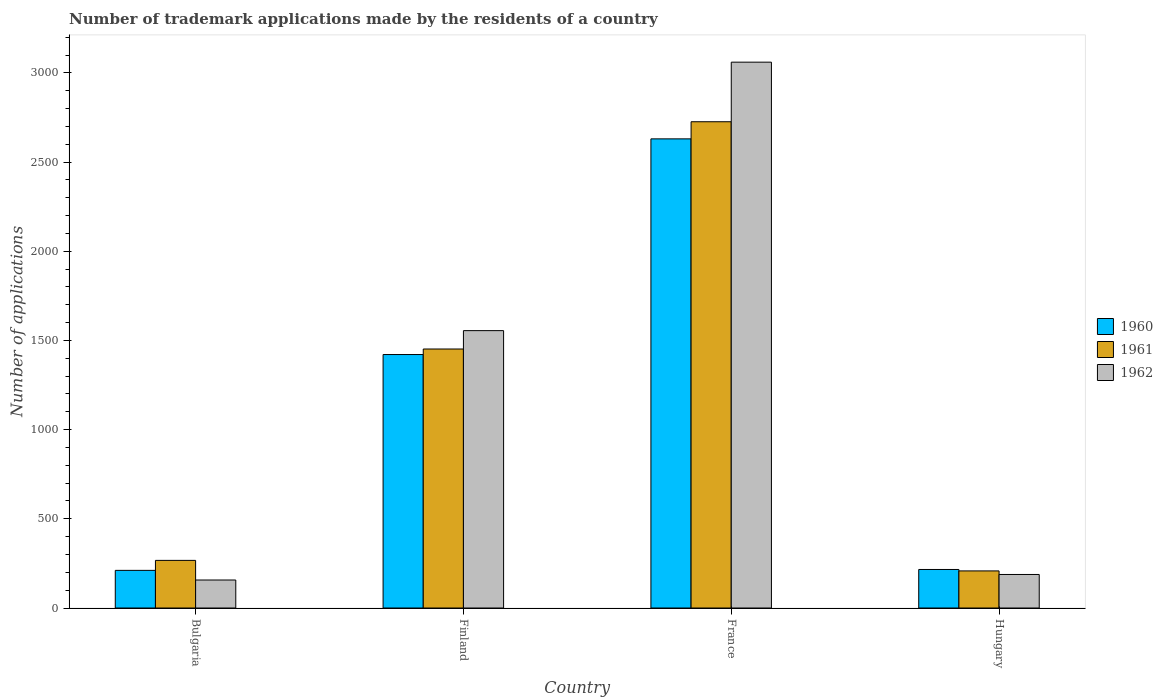How many groups of bars are there?
Give a very brief answer. 4. Are the number of bars per tick equal to the number of legend labels?
Your response must be concise. Yes. What is the label of the 4th group of bars from the left?
Provide a short and direct response. Hungary. What is the number of trademark applications made by the residents in 1961 in Bulgaria?
Offer a very short reply. 267. Across all countries, what is the maximum number of trademark applications made by the residents in 1961?
Offer a very short reply. 2726. Across all countries, what is the minimum number of trademark applications made by the residents in 1961?
Keep it short and to the point. 208. In which country was the number of trademark applications made by the residents in 1961 maximum?
Your answer should be compact. France. In which country was the number of trademark applications made by the residents in 1962 minimum?
Offer a very short reply. Bulgaria. What is the total number of trademark applications made by the residents in 1960 in the graph?
Provide a succinct answer. 4478. What is the difference between the number of trademark applications made by the residents in 1960 in Bulgaria and that in Finland?
Make the answer very short. -1210. What is the difference between the number of trademark applications made by the residents in 1961 in Bulgaria and the number of trademark applications made by the residents in 1962 in Hungary?
Provide a succinct answer. 79. What is the average number of trademark applications made by the residents in 1961 per country?
Your response must be concise. 1163.25. What is the difference between the number of trademark applications made by the residents of/in 1962 and number of trademark applications made by the residents of/in 1960 in Finland?
Make the answer very short. 134. In how many countries, is the number of trademark applications made by the residents in 1961 greater than 100?
Your answer should be very brief. 4. What is the ratio of the number of trademark applications made by the residents in 1960 in Finland to that in France?
Your response must be concise. 0.54. Is the number of trademark applications made by the residents in 1961 in Finland less than that in Hungary?
Provide a short and direct response. No. Is the difference between the number of trademark applications made by the residents in 1962 in Bulgaria and France greater than the difference between the number of trademark applications made by the residents in 1960 in Bulgaria and France?
Give a very brief answer. No. What is the difference between the highest and the second highest number of trademark applications made by the residents in 1961?
Offer a terse response. -1185. What is the difference between the highest and the lowest number of trademark applications made by the residents in 1962?
Your answer should be compact. 2903. Is it the case that in every country, the sum of the number of trademark applications made by the residents in 1962 and number of trademark applications made by the residents in 1960 is greater than the number of trademark applications made by the residents in 1961?
Offer a terse response. Yes. How many countries are there in the graph?
Provide a short and direct response. 4. Does the graph contain any zero values?
Keep it short and to the point. No. Does the graph contain grids?
Provide a succinct answer. No. Where does the legend appear in the graph?
Offer a terse response. Center right. How many legend labels are there?
Offer a terse response. 3. How are the legend labels stacked?
Provide a short and direct response. Vertical. What is the title of the graph?
Keep it short and to the point. Number of trademark applications made by the residents of a country. Does "1969" appear as one of the legend labels in the graph?
Offer a terse response. No. What is the label or title of the X-axis?
Give a very brief answer. Country. What is the label or title of the Y-axis?
Your answer should be very brief. Number of applications. What is the Number of applications of 1960 in Bulgaria?
Your answer should be compact. 211. What is the Number of applications of 1961 in Bulgaria?
Ensure brevity in your answer.  267. What is the Number of applications in 1962 in Bulgaria?
Ensure brevity in your answer.  157. What is the Number of applications in 1960 in Finland?
Provide a succinct answer. 1421. What is the Number of applications of 1961 in Finland?
Your response must be concise. 1452. What is the Number of applications in 1962 in Finland?
Your answer should be compact. 1555. What is the Number of applications in 1960 in France?
Your response must be concise. 2630. What is the Number of applications of 1961 in France?
Your answer should be compact. 2726. What is the Number of applications of 1962 in France?
Offer a very short reply. 3060. What is the Number of applications in 1960 in Hungary?
Provide a succinct answer. 216. What is the Number of applications in 1961 in Hungary?
Make the answer very short. 208. What is the Number of applications of 1962 in Hungary?
Keep it short and to the point. 188. Across all countries, what is the maximum Number of applications of 1960?
Your answer should be compact. 2630. Across all countries, what is the maximum Number of applications of 1961?
Your answer should be compact. 2726. Across all countries, what is the maximum Number of applications in 1962?
Make the answer very short. 3060. Across all countries, what is the minimum Number of applications in 1960?
Keep it short and to the point. 211. Across all countries, what is the minimum Number of applications in 1961?
Your answer should be very brief. 208. Across all countries, what is the minimum Number of applications in 1962?
Your answer should be very brief. 157. What is the total Number of applications in 1960 in the graph?
Provide a short and direct response. 4478. What is the total Number of applications of 1961 in the graph?
Your answer should be compact. 4653. What is the total Number of applications of 1962 in the graph?
Offer a very short reply. 4960. What is the difference between the Number of applications of 1960 in Bulgaria and that in Finland?
Offer a very short reply. -1210. What is the difference between the Number of applications in 1961 in Bulgaria and that in Finland?
Your answer should be compact. -1185. What is the difference between the Number of applications in 1962 in Bulgaria and that in Finland?
Make the answer very short. -1398. What is the difference between the Number of applications in 1960 in Bulgaria and that in France?
Provide a short and direct response. -2419. What is the difference between the Number of applications in 1961 in Bulgaria and that in France?
Keep it short and to the point. -2459. What is the difference between the Number of applications of 1962 in Bulgaria and that in France?
Your answer should be very brief. -2903. What is the difference between the Number of applications in 1962 in Bulgaria and that in Hungary?
Provide a short and direct response. -31. What is the difference between the Number of applications of 1960 in Finland and that in France?
Offer a terse response. -1209. What is the difference between the Number of applications of 1961 in Finland and that in France?
Ensure brevity in your answer.  -1274. What is the difference between the Number of applications of 1962 in Finland and that in France?
Ensure brevity in your answer.  -1505. What is the difference between the Number of applications of 1960 in Finland and that in Hungary?
Offer a very short reply. 1205. What is the difference between the Number of applications of 1961 in Finland and that in Hungary?
Your answer should be very brief. 1244. What is the difference between the Number of applications of 1962 in Finland and that in Hungary?
Give a very brief answer. 1367. What is the difference between the Number of applications of 1960 in France and that in Hungary?
Offer a terse response. 2414. What is the difference between the Number of applications of 1961 in France and that in Hungary?
Your answer should be very brief. 2518. What is the difference between the Number of applications of 1962 in France and that in Hungary?
Offer a terse response. 2872. What is the difference between the Number of applications in 1960 in Bulgaria and the Number of applications in 1961 in Finland?
Provide a short and direct response. -1241. What is the difference between the Number of applications in 1960 in Bulgaria and the Number of applications in 1962 in Finland?
Provide a short and direct response. -1344. What is the difference between the Number of applications in 1961 in Bulgaria and the Number of applications in 1962 in Finland?
Ensure brevity in your answer.  -1288. What is the difference between the Number of applications in 1960 in Bulgaria and the Number of applications in 1961 in France?
Your answer should be compact. -2515. What is the difference between the Number of applications of 1960 in Bulgaria and the Number of applications of 1962 in France?
Give a very brief answer. -2849. What is the difference between the Number of applications of 1961 in Bulgaria and the Number of applications of 1962 in France?
Make the answer very short. -2793. What is the difference between the Number of applications in 1960 in Bulgaria and the Number of applications in 1961 in Hungary?
Your response must be concise. 3. What is the difference between the Number of applications in 1960 in Bulgaria and the Number of applications in 1962 in Hungary?
Your answer should be very brief. 23. What is the difference between the Number of applications of 1961 in Bulgaria and the Number of applications of 1962 in Hungary?
Offer a very short reply. 79. What is the difference between the Number of applications of 1960 in Finland and the Number of applications of 1961 in France?
Provide a succinct answer. -1305. What is the difference between the Number of applications in 1960 in Finland and the Number of applications in 1962 in France?
Offer a terse response. -1639. What is the difference between the Number of applications of 1961 in Finland and the Number of applications of 1962 in France?
Your answer should be very brief. -1608. What is the difference between the Number of applications of 1960 in Finland and the Number of applications of 1961 in Hungary?
Ensure brevity in your answer.  1213. What is the difference between the Number of applications of 1960 in Finland and the Number of applications of 1962 in Hungary?
Offer a very short reply. 1233. What is the difference between the Number of applications in 1961 in Finland and the Number of applications in 1962 in Hungary?
Offer a terse response. 1264. What is the difference between the Number of applications in 1960 in France and the Number of applications in 1961 in Hungary?
Ensure brevity in your answer.  2422. What is the difference between the Number of applications in 1960 in France and the Number of applications in 1962 in Hungary?
Offer a terse response. 2442. What is the difference between the Number of applications of 1961 in France and the Number of applications of 1962 in Hungary?
Provide a succinct answer. 2538. What is the average Number of applications in 1960 per country?
Give a very brief answer. 1119.5. What is the average Number of applications in 1961 per country?
Your answer should be compact. 1163.25. What is the average Number of applications in 1962 per country?
Keep it short and to the point. 1240. What is the difference between the Number of applications of 1960 and Number of applications of 1961 in Bulgaria?
Ensure brevity in your answer.  -56. What is the difference between the Number of applications in 1960 and Number of applications in 1962 in Bulgaria?
Your answer should be compact. 54. What is the difference between the Number of applications in 1961 and Number of applications in 1962 in Bulgaria?
Ensure brevity in your answer.  110. What is the difference between the Number of applications in 1960 and Number of applications in 1961 in Finland?
Your answer should be very brief. -31. What is the difference between the Number of applications in 1960 and Number of applications in 1962 in Finland?
Keep it short and to the point. -134. What is the difference between the Number of applications of 1961 and Number of applications of 1962 in Finland?
Provide a short and direct response. -103. What is the difference between the Number of applications in 1960 and Number of applications in 1961 in France?
Offer a very short reply. -96. What is the difference between the Number of applications of 1960 and Number of applications of 1962 in France?
Provide a succinct answer. -430. What is the difference between the Number of applications of 1961 and Number of applications of 1962 in France?
Give a very brief answer. -334. What is the ratio of the Number of applications of 1960 in Bulgaria to that in Finland?
Your response must be concise. 0.15. What is the ratio of the Number of applications in 1961 in Bulgaria to that in Finland?
Keep it short and to the point. 0.18. What is the ratio of the Number of applications of 1962 in Bulgaria to that in Finland?
Keep it short and to the point. 0.1. What is the ratio of the Number of applications of 1960 in Bulgaria to that in France?
Offer a terse response. 0.08. What is the ratio of the Number of applications in 1961 in Bulgaria to that in France?
Your response must be concise. 0.1. What is the ratio of the Number of applications in 1962 in Bulgaria to that in France?
Offer a terse response. 0.05. What is the ratio of the Number of applications in 1960 in Bulgaria to that in Hungary?
Provide a succinct answer. 0.98. What is the ratio of the Number of applications in 1961 in Bulgaria to that in Hungary?
Offer a terse response. 1.28. What is the ratio of the Number of applications of 1962 in Bulgaria to that in Hungary?
Your answer should be very brief. 0.84. What is the ratio of the Number of applications in 1960 in Finland to that in France?
Offer a terse response. 0.54. What is the ratio of the Number of applications in 1961 in Finland to that in France?
Ensure brevity in your answer.  0.53. What is the ratio of the Number of applications in 1962 in Finland to that in France?
Your answer should be very brief. 0.51. What is the ratio of the Number of applications of 1960 in Finland to that in Hungary?
Ensure brevity in your answer.  6.58. What is the ratio of the Number of applications in 1961 in Finland to that in Hungary?
Give a very brief answer. 6.98. What is the ratio of the Number of applications of 1962 in Finland to that in Hungary?
Your answer should be very brief. 8.27. What is the ratio of the Number of applications in 1960 in France to that in Hungary?
Your answer should be compact. 12.18. What is the ratio of the Number of applications in 1961 in France to that in Hungary?
Offer a terse response. 13.11. What is the ratio of the Number of applications of 1962 in France to that in Hungary?
Offer a very short reply. 16.28. What is the difference between the highest and the second highest Number of applications of 1960?
Your response must be concise. 1209. What is the difference between the highest and the second highest Number of applications of 1961?
Give a very brief answer. 1274. What is the difference between the highest and the second highest Number of applications of 1962?
Give a very brief answer. 1505. What is the difference between the highest and the lowest Number of applications in 1960?
Give a very brief answer. 2419. What is the difference between the highest and the lowest Number of applications of 1961?
Ensure brevity in your answer.  2518. What is the difference between the highest and the lowest Number of applications of 1962?
Offer a very short reply. 2903. 